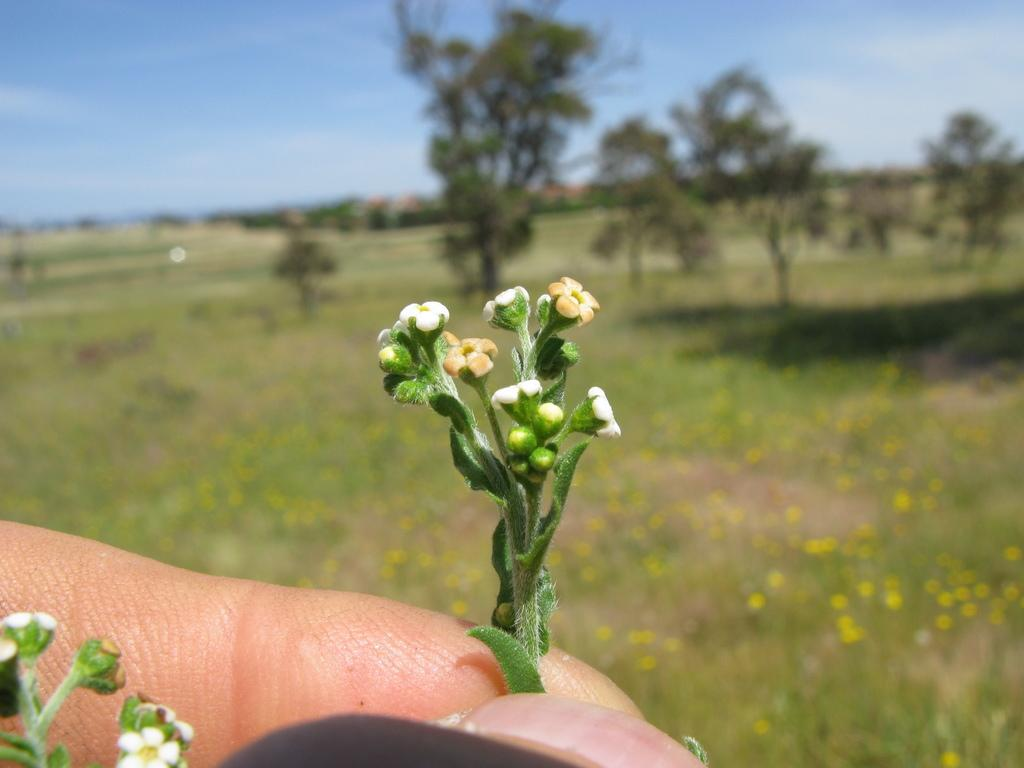What body part is visible in the image? There are person's fingers visible in the image. What is the person holding in the image? The person is holding a plant. What type of plants can be seen in the background of the image? There are flower plants and trees in the background of the image. What part of the natural environment is visible in the image? The sky is visible in the background of the image. What type of sidewalk can be seen in the image? There is no sidewalk present in the image. 